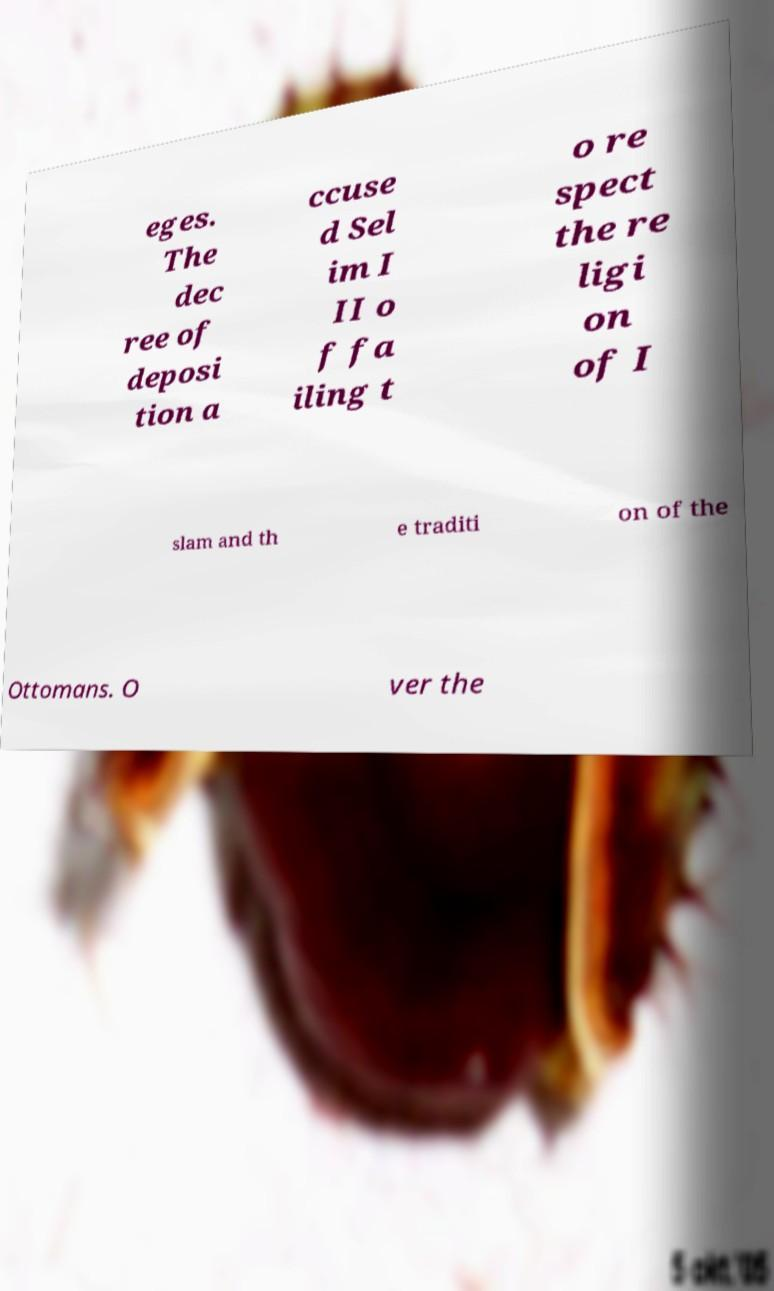For documentation purposes, I need the text within this image transcribed. Could you provide that? eges. The dec ree of deposi tion a ccuse d Sel im I II o f fa iling t o re spect the re ligi on of I slam and th e traditi on of the Ottomans. O ver the 